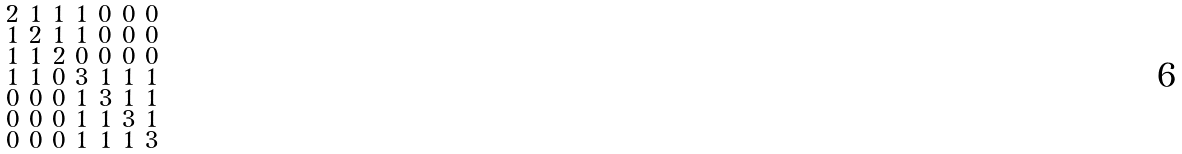<formula> <loc_0><loc_0><loc_500><loc_500>\begin{smallmatrix} 2 & 1 & 1 & 1 & 0 & 0 & 0 \\ 1 & 2 & 1 & 1 & 0 & 0 & 0 \\ 1 & 1 & 2 & 0 & 0 & 0 & 0 \\ 1 & 1 & 0 & 3 & 1 & 1 & 1 \\ 0 & 0 & 0 & 1 & 3 & 1 & 1 \\ 0 & 0 & 0 & 1 & 1 & 3 & 1 \\ 0 & 0 & 0 & 1 & 1 & 1 & 3 \end{smallmatrix}</formula> 